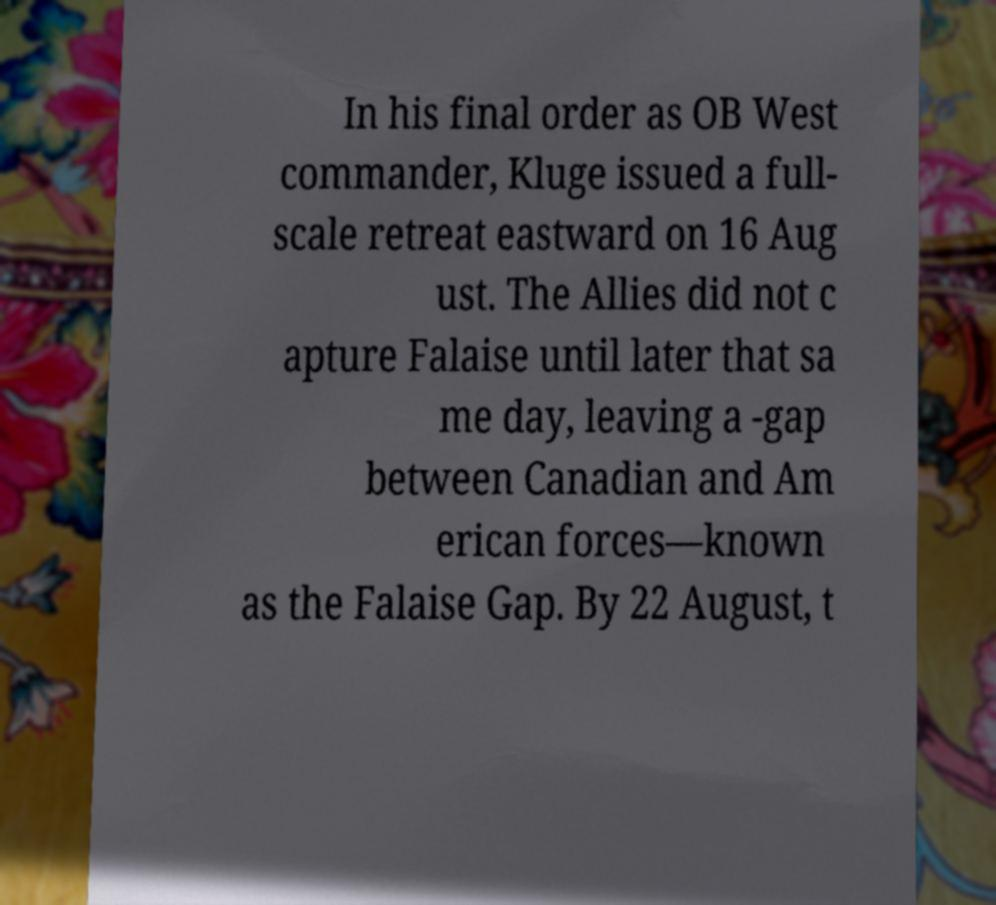For documentation purposes, I need the text within this image transcribed. Could you provide that? In his final order as OB West commander, Kluge issued a full- scale retreat eastward on 16 Aug ust. The Allies did not c apture Falaise until later that sa me day, leaving a -gap between Canadian and Am erican forces—known as the Falaise Gap. By 22 August, t 